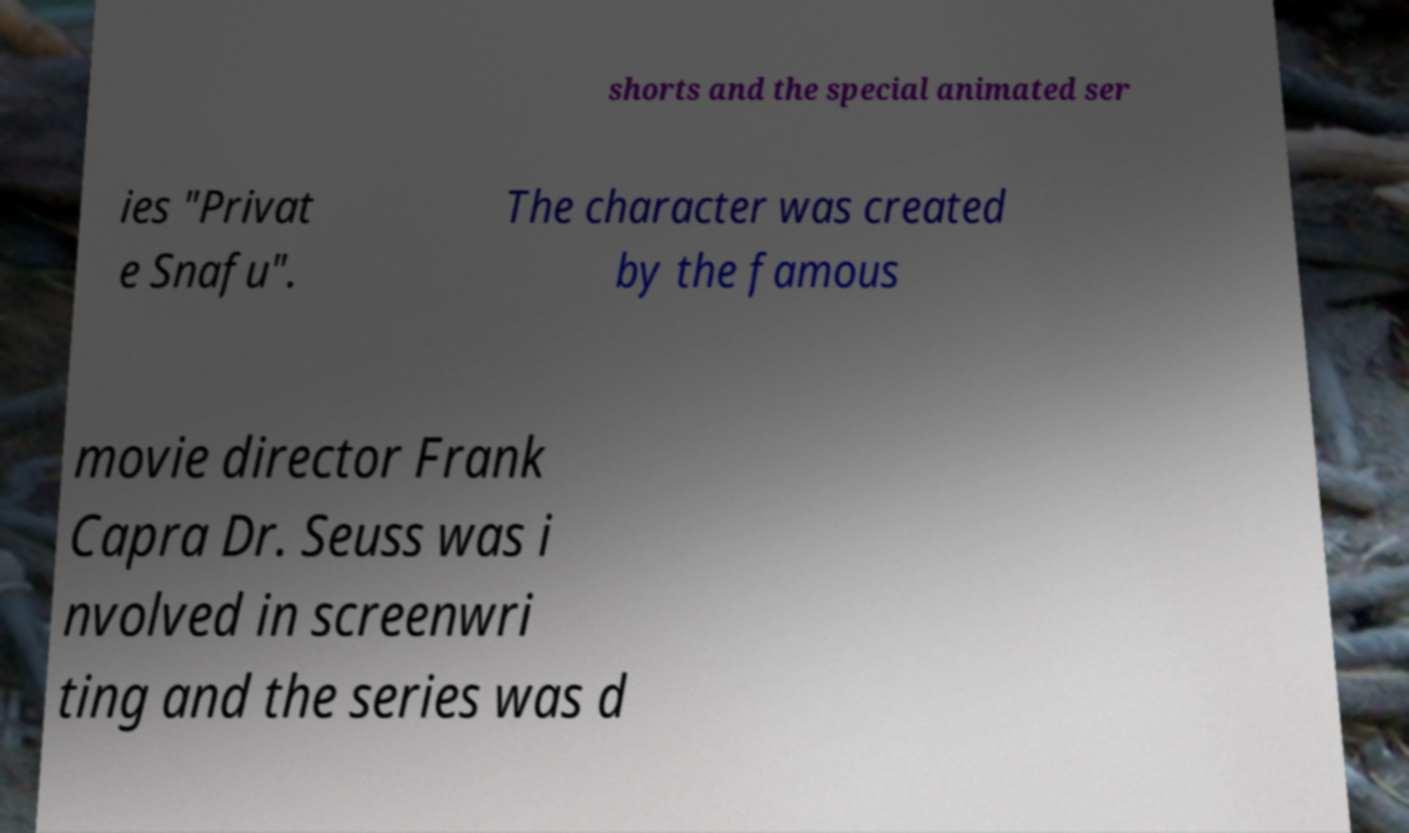Could you extract and type out the text from this image? shorts and the special animated ser ies "Privat e Snafu". The character was created by the famous movie director Frank Capra Dr. Seuss was i nvolved in screenwri ting and the series was d 